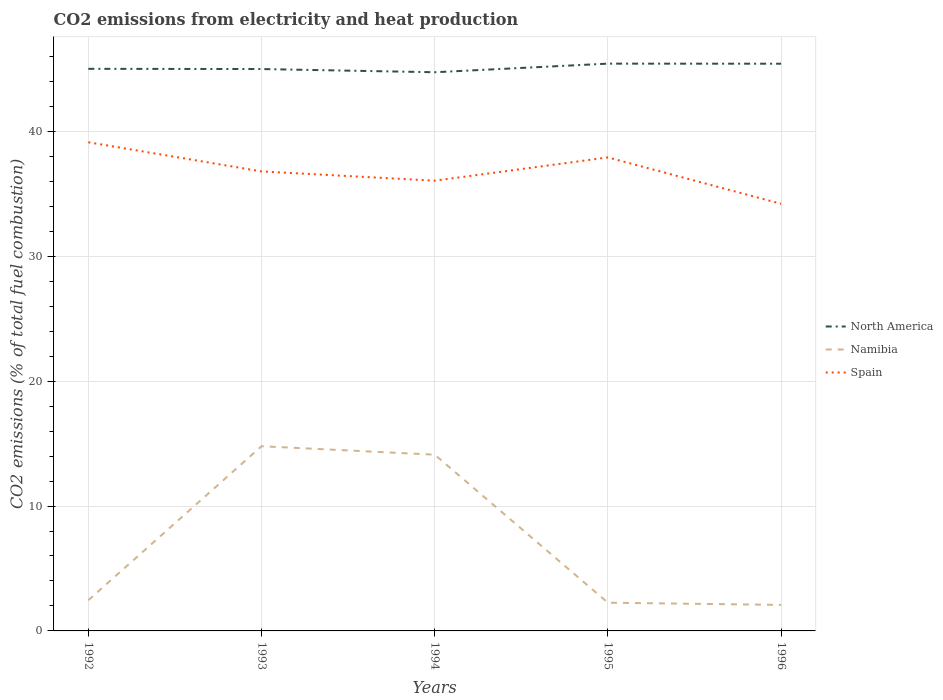How many different coloured lines are there?
Offer a very short reply. 3. Across all years, what is the maximum amount of CO2 emitted in North America?
Your response must be concise. 44.73. In which year was the amount of CO2 emitted in Spain maximum?
Your response must be concise. 1996. What is the total amount of CO2 emitted in Namibia in the graph?
Offer a very short reply. 0.68. What is the difference between the highest and the second highest amount of CO2 emitted in Spain?
Offer a terse response. 4.93. How many years are there in the graph?
Provide a short and direct response. 5. What is the difference between two consecutive major ticks on the Y-axis?
Your answer should be compact. 10. Are the values on the major ticks of Y-axis written in scientific E-notation?
Offer a very short reply. No. Does the graph contain any zero values?
Provide a succinct answer. No. How are the legend labels stacked?
Ensure brevity in your answer.  Vertical. What is the title of the graph?
Make the answer very short. CO2 emissions from electricity and heat production. What is the label or title of the Y-axis?
Your response must be concise. CO2 emissions (% of total fuel combustion). What is the CO2 emissions (% of total fuel combustion) of North America in 1992?
Make the answer very short. 45.01. What is the CO2 emissions (% of total fuel combustion) of Namibia in 1992?
Offer a terse response. 2.46. What is the CO2 emissions (% of total fuel combustion) of Spain in 1992?
Offer a very short reply. 39.12. What is the CO2 emissions (% of total fuel combustion) of North America in 1993?
Provide a short and direct response. 44.99. What is the CO2 emissions (% of total fuel combustion) of Namibia in 1993?
Your answer should be very brief. 14.79. What is the CO2 emissions (% of total fuel combustion) of Spain in 1993?
Give a very brief answer. 36.79. What is the CO2 emissions (% of total fuel combustion) in North America in 1994?
Keep it short and to the point. 44.73. What is the CO2 emissions (% of total fuel combustion) of Namibia in 1994?
Offer a very short reply. 14.11. What is the CO2 emissions (% of total fuel combustion) in Spain in 1994?
Provide a short and direct response. 36.05. What is the CO2 emissions (% of total fuel combustion) in North America in 1995?
Offer a very short reply. 45.42. What is the CO2 emissions (% of total fuel combustion) of Namibia in 1995?
Give a very brief answer. 2.26. What is the CO2 emissions (% of total fuel combustion) in Spain in 1995?
Provide a short and direct response. 37.91. What is the CO2 emissions (% of total fuel combustion) in North America in 1996?
Your answer should be very brief. 45.42. What is the CO2 emissions (% of total fuel combustion) of Namibia in 1996?
Keep it short and to the point. 2.08. What is the CO2 emissions (% of total fuel combustion) in Spain in 1996?
Make the answer very short. 34.2. Across all years, what is the maximum CO2 emissions (% of total fuel combustion) in North America?
Keep it short and to the point. 45.42. Across all years, what is the maximum CO2 emissions (% of total fuel combustion) of Namibia?
Provide a short and direct response. 14.79. Across all years, what is the maximum CO2 emissions (% of total fuel combustion) of Spain?
Ensure brevity in your answer.  39.12. Across all years, what is the minimum CO2 emissions (% of total fuel combustion) in North America?
Ensure brevity in your answer.  44.73. Across all years, what is the minimum CO2 emissions (% of total fuel combustion) of Namibia?
Provide a short and direct response. 2.08. Across all years, what is the minimum CO2 emissions (% of total fuel combustion) in Spain?
Your answer should be very brief. 34.2. What is the total CO2 emissions (% of total fuel combustion) in North America in the graph?
Offer a terse response. 225.56. What is the total CO2 emissions (% of total fuel combustion) in Namibia in the graph?
Your response must be concise. 35.7. What is the total CO2 emissions (% of total fuel combustion) of Spain in the graph?
Your answer should be compact. 184.08. What is the difference between the CO2 emissions (% of total fuel combustion) of North America in 1992 and that in 1993?
Your answer should be compact. 0.02. What is the difference between the CO2 emissions (% of total fuel combustion) of Namibia in 1992 and that in 1993?
Provide a succinct answer. -12.33. What is the difference between the CO2 emissions (% of total fuel combustion) of Spain in 1992 and that in 1993?
Ensure brevity in your answer.  2.33. What is the difference between the CO2 emissions (% of total fuel combustion) of North America in 1992 and that in 1994?
Give a very brief answer. 0.27. What is the difference between the CO2 emissions (% of total fuel combustion) in Namibia in 1992 and that in 1994?
Your answer should be compact. -11.65. What is the difference between the CO2 emissions (% of total fuel combustion) in Spain in 1992 and that in 1994?
Your answer should be compact. 3.08. What is the difference between the CO2 emissions (% of total fuel combustion) of North America in 1992 and that in 1995?
Keep it short and to the point. -0.42. What is the difference between the CO2 emissions (% of total fuel combustion) of Namibia in 1992 and that in 1995?
Your answer should be very brief. 0.2. What is the difference between the CO2 emissions (% of total fuel combustion) of Spain in 1992 and that in 1995?
Your response must be concise. 1.21. What is the difference between the CO2 emissions (% of total fuel combustion) in North America in 1992 and that in 1996?
Give a very brief answer. -0.41. What is the difference between the CO2 emissions (% of total fuel combustion) of Namibia in 1992 and that in 1996?
Your answer should be compact. 0.38. What is the difference between the CO2 emissions (% of total fuel combustion) of Spain in 1992 and that in 1996?
Make the answer very short. 4.93. What is the difference between the CO2 emissions (% of total fuel combustion) in North America in 1993 and that in 1994?
Your response must be concise. 0.26. What is the difference between the CO2 emissions (% of total fuel combustion) of Namibia in 1993 and that in 1994?
Your response must be concise. 0.68. What is the difference between the CO2 emissions (% of total fuel combustion) in Spain in 1993 and that in 1994?
Offer a very short reply. 0.74. What is the difference between the CO2 emissions (% of total fuel combustion) in North America in 1993 and that in 1995?
Your response must be concise. -0.43. What is the difference between the CO2 emissions (% of total fuel combustion) in Namibia in 1993 and that in 1995?
Your answer should be compact. 12.53. What is the difference between the CO2 emissions (% of total fuel combustion) in Spain in 1993 and that in 1995?
Give a very brief answer. -1.12. What is the difference between the CO2 emissions (% of total fuel combustion) in North America in 1993 and that in 1996?
Keep it short and to the point. -0.43. What is the difference between the CO2 emissions (% of total fuel combustion) of Namibia in 1993 and that in 1996?
Offer a terse response. 12.71. What is the difference between the CO2 emissions (% of total fuel combustion) in Spain in 1993 and that in 1996?
Your answer should be very brief. 2.59. What is the difference between the CO2 emissions (% of total fuel combustion) in North America in 1994 and that in 1995?
Keep it short and to the point. -0.69. What is the difference between the CO2 emissions (% of total fuel combustion) in Namibia in 1994 and that in 1995?
Offer a very short reply. 11.85. What is the difference between the CO2 emissions (% of total fuel combustion) of Spain in 1994 and that in 1995?
Offer a terse response. -1.86. What is the difference between the CO2 emissions (% of total fuel combustion) of North America in 1994 and that in 1996?
Offer a very short reply. -0.68. What is the difference between the CO2 emissions (% of total fuel combustion) in Namibia in 1994 and that in 1996?
Give a very brief answer. 12.03. What is the difference between the CO2 emissions (% of total fuel combustion) in Spain in 1994 and that in 1996?
Give a very brief answer. 1.85. What is the difference between the CO2 emissions (% of total fuel combustion) of North America in 1995 and that in 1996?
Offer a terse response. 0.01. What is the difference between the CO2 emissions (% of total fuel combustion) in Namibia in 1995 and that in 1996?
Your response must be concise. 0.18. What is the difference between the CO2 emissions (% of total fuel combustion) of Spain in 1995 and that in 1996?
Offer a terse response. 3.71. What is the difference between the CO2 emissions (% of total fuel combustion) in North America in 1992 and the CO2 emissions (% of total fuel combustion) in Namibia in 1993?
Provide a succinct answer. 30.22. What is the difference between the CO2 emissions (% of total fuel combustion) in North America in 1992 and the CO2 emissions (% of total fuel combustion) in Spain in 1993?
Your answer should be compact. 8.21. What is the difference between the CO2 emissions (% of total fuel combustion) in Namibia in 1992 and the CO2 emissions (% of total fuel combustion) in Spain in 1993?
Ensure brevity in your answer.  -34.33. What is the difference between the CO2 emissions (% of total fuel combustion) of North America in 1992 and the CO2 emissions (% of total fuel combustion) of Namibia in 1994?
Provide a succinct answer. 30.9. What is the difference between the CO2 emissions (% of total fuel combustion) in North America in 1992 and the CO2 emissions (% of total fuel combustion) in Spain in 1994?
Your answer should be compact. 8.96. What is the difference between the CO2 emissions (% of total fuel combustion) of Namibia in 1992 and the CO2 emissions (% of total fuel combustion) of Spain in 1994?
Your answer should be compact. -33.59. What is the difference between the CO2 emissions (% of total fuel combustion) in North America in 1992 and the CO2 emissions (% of total fuel combustion) in Namibia in 1995?
Keep it short and to the point. 42.75. What is the difference between the CO2 emissions (% of total fuel combustion) of North America in 1992 and the CO2 emissions (% of total fuel combustion) of Spain in 1995?
Make the answer very short. 7.09. What is the difference between the CO2 emissions (% of total fuel combustion) of Namibia in 1992 and the CO2 emissions (% of total fuel combustion) of Spain in 1995?
Your answer should be very brief. -35.45. What is the difference between the CO2 emissions (% of total fuel combustion) in North America in 1992 and the CO2 emissions (% of total fuel combustion) in Namibia in 1996?
Keep it short and to the point. 42.92. What is the difference between the CO2 emissions (% of total fuel combustion) in North America in 1992 and the CO2 emissions (% of total fuel combustion) in Spain in 1996?
Ensure brevity in your answer.  10.81. What is the difference between the CO2 emissions (% of total fuel combustion) in Namibia in 1992 and the CO2 emissions (% of total fuel combustion) in Spain in 1996?
Your answer should be very brief. -31.74. What is the difference between the CO2 emissions (% of total fuel combustion) of North America in 1993 and the CO2 emissions (% of total fuel combustion) of Namibia in 1994?
Ensure brevity in your answer.  30.88. What is the difference between the CO2 emissions (% of total fuel combustion) of North America in 1993 and the CO2 emissions (% of total fuel combustion) of Spain in 1994?
Offer a terse response. 8.94. What is the difference between the CO2 emissions (% of total fuel combustion) in Namibia in 1993 and the CO2 emissions (% of total fuel combustion) in Spain in 1994?
Your answer should be compact. -21.26. What is the difference between the CO2 emissions (% of total fuel combustion) of North America in 1993 and the CO2 emissions (% of total fuel combustion) of Namibia in 1995?
Provide a short and direct response. 42.73. What is the difference between the CO2 emissions (% of total fuel combustion) in North America in 1993 and the CO2 emissions (% of total fuel combustion) in Spain in 1995?
Make the answer very short. 7.07. What is the difference between the CO2 emissions (% of total fuel combustion) of Namibia in 1993 and the CO2 emissions (% of total fuel combustion) of Spain in 1995?
Offer a terse response. -23.12. What is the difference between the CO2 emissions (% of total fuel combustion) in North America in 1993 and the CO2 emissions (% of total fuel combustion) in Namibia in 1996?
Your answer should be compact. 42.9. What is the difference between the CO2 emissions (% of total fuel combustion) in North America in 1993 and the CO2 emissions (% of total fuel combustion) in Spain in 1996?
Ensure brevity in your answer.  10.79. What is the difference between the CO2 emissions (% of total fuel combustion) of Namibia in 1993 and the CO2 emissions (% of total fuel combustion) of Spain in 1996?
Your answer should be compact. -19.41. What is the difference between the CO2 emissions (% of total fuel combustion) in North America in 1994 and the CO2 emissions (% of total fuel combustion) in Namibia in 1995?
Keep it short and to the point. 42.47. What is the difference between the CO2 emissions (% of total fuel combustion) in North America in 1994 and the CO2 emissions (% of total fuel combustion) in Spain in 1995?
Offer a very short reply. 6.82. What is the difference between the CO2 emissions (% of total fuel combustion) of Namibia in 1994 and the CO2 emissions (% of total fuel combustion) of Spain in 1995?
Your answer should be compact. -23.8. What is the difference between the CO2 emissions (% of total fuel combustion) in North America in 1994 and the CO2 emissions (% of total fuel combustion) in Namibia in 1996?
Your response must be concise. 42.65. What is the difference between the CO2 emissions (% of total fuel combustion) in North America in 1994 and the CO2 emissions (% of total fuel combustion) in Spain in 1996?
Give a very brief answer. 10.53. What is the difference between the CO2 emissions (% of total fuel combustion) in Namibia in 1994 and the CO2 emissions (% of total fuel combustion) in Spain in 1996?
Offer a terse response. -20.09. What is the difference between the CO2 emissions (% of total fuel combustion) in North America in 1995 and the CO2 emissions (% of total fuel combustion) in Namibia in 1996?
Your answer should be compact. 43.34. What is the difference between the CO2 emissions (% of total fuel combustion) in North America in 1995 and the CO2 emissions (% of total fuel combustion) in Spain in 1996?
Offer a terse response. 11.22. What is the difference between the CO2 emissions (% of total fuel combustion) of Namibia in 1995 and the CO2 emissions (% of total fuel combustion) of Spain in 1996?
Provide a succinct answer. -31.94. What is the average CO2 emissions (% of total fuel combustion) in North America per year?
Ensure brevity in your answer.  45.11. What is the average CO2 emissions (% of total fuel combustion) in Namibia per year?
Offer a terse response. 7.14. What is the average CO2 emissions (% of total fuel combustion) in Spain per year?
Your response must be concise. 36.82. In the year 1992, what is the difference between the CO2 emissions (% of total fuel combustion) of North America and CO2 emissions (% of total fuel combustion) of Namibia?
Your answer should be very brief. 42.55. In the year 1992, what is the difference between the CO2 emissions (% of total fuel combustion) in North America and CO2 emissions (% of total fuel combustion) in Spain?
Offer a very short reply. 5.88. In the year 1992, what is the difference between the CO2 emissions (% of total fuel combustion) in Namibia and CO2 emissions (% of total fuel combustion) in Spain?
Offer a very short reply. -36.67. In the year 1993, what is the difference between the CO2 emissions (% of total fuel combustion) in North America and CO2 emissions (% of total fuel combustion) in Namibia?
Your response must be concise. 30.2. In the year 1993, what is the difference between the CO2 emissions (% of total fuel combustion) of North America and CO2 emissions (% of total fuel combustion) of Spain?
Make the answer very short. 8.2. In the year 1993, what is the difference between the CO2 emissions (% of total fuel combustion) in Namibia and CO2 emissions (% of total fuel combustion) in Spain?
Provide a short and direct response. -22. In the year 1994, what is the difference between the CO2 emissions (% of total fuel combustion) in North America and CO2 emissions (% of total fuel combustion) in Namibia?
Your response must be concise. 30.62. In the year 1994, what is the difference between the CO2 emissions (% of total fuel combustion) of North America and CO2 emissions (% of total fuel combustion) of Spain?
Give a very brief answer. 8.68. In the year 1994, what is the difference between the CO2 emissions (% of total fuel combustion) in Namibia and CO2 emissions (% of total fuel combustion) in Spain?
Ensure brevity in your answer.  -21.94. In the year 1995, what is the difference between the CO2 emissions (% of total fuel combustion) in North America and CO2 emissions (% of total fuel combustion) in Namibia?
Offer a very short reply. 43.16. In the year 1995, what is the difference between the CO2 emissions (% of total fuel combustion) of North America and CO2 emissions (% of total fuel combustion) of Spain?
Provide a short and direct response. 7.51. In the year 1995, what is the difference between the CO2 emissions (% of total fuel combustion) in Namibia and CO2 emissions (% of total fuel combustion) in Spain?
Offer a very short reply. -35.65. In the year 1996, what is the difference between the CO2 emissions (% of total fuel combustion) in North America and CO2 emissions (% of total fuel combustion) in Namibia?
Provide a short and direct response. 43.33. In the year 1996, what is the difference between the CO2 emissions (% of total fuel combustion) in North America and CO2 emissions (% of total fuel combustion) in Spain?
Ensure brevity in your answer.  11.22. In the year 1996, what is the difference between the CO2 emissions (% of total fuel combustion) in Namibia and CO2 emissions (% of total fuel combustion) in Spain?
Keep it short and to the point. -32.11. What is the ratio of the CO2 emissions (% of total fuel combustion) of North America in 1992 to that in 1993?
Provide a succinct answer. 1. What is the ratio of the CO2 emissions (% of total fuel combustion) in Namibia in 1992 to that in 1993?
Offer a terse response. 0.17. What is the ratio of the CO2 emissions (% of total fuel combustion) in Spain in 1992 to that in 1993?
Give a very brief answer. 1.06. What is the ratio of the CO2 emissions (% of total fuel combustion) of Namibia in 1992 to that in 1994?
Your answer should be compact. 0.17. What is the ratio of the CO2 emissions (% of total fuel combustion) in Spain in 1992 to that in 1994?
Offer a terse response. 1.09. What is the ratio of the CO2 emissions (% of total fuel combustion) in North America in 1992 to that in 1995?
Provide a short and direct response. 0.99. What is the ratio of the CO2 emissions (% of total fuel combustion) in Namibia in 1992 to that in 1995?
Keep it short and to the point. 1.09. What is the ratio of the CO2 emissions (% of total fuel combustion) in Spain in 1992 to that in 1995?
Offer a terse response. 1.03. What is the ratio of the CO2 emissions (% of total fuel combustion) of Namibia in 1992 to that in 1996?
Keep it short and to the point. 1.18. What is the ratio of the CO2 emissions (% of total fuel combustion) in Spain in 1992 to that in 1996?
Provide a succinct answer. 1.14. What is the ratio of the CO2 emissions (% of total fuel combustion) in North America in 1993 to that in 1994?
Your answer should be very brief. 1.01. What is the ratio of the CO2 emissions (% of total fuel combustion) of Namibia in 1993 to that in 1994?
Make the answer very short. 1.05. What is the ratio of the CO2 emissions (% of total fuel combustion) in Spain in 1993 to that in 1994?
Provide a short and direct response. 1.02. What is the ratio of the CO2 emissions (% of total fuel combustion) in North America in 1993 to that in 1995?
Your answer should be compact. 0.99. What is the ratio of the CO2 emissions (% of total fuel combustion) in Namibia in 1993 to that in 1995?
Make the answer very short. 6.54. What is the ratio of the CO2 emissions (% of total fuel combustion) in Spain in 1993 to that in 1995?
Offer a terse response. 0.97. What is the ratio of the CO2 emissions (% of total fuel combustion) in North America in 1993 to that in 1996?
Your answer should be very brief. 0.99. What is the ratio of the CO2 emissions (% of total fuel combustion) of Namibia in 1993 to that in 1996?
Your response must be concise. 7.1. What is the ratio of the CO2 emissions (% of total fuel combustion) of Spain in 1993 to that in 1996?
Offer a terse response. 1.08. What is the ratio of the CO2 emissions (% of total fuel combustion) of Namibia in 1994 to that in 1995?
Provide a succinct answer. 6.24. What is the ratio of the CO2 emissions (% of total fuel combustion) of Spain in 1994 to that in 1995?
Provide a succinct answer. 0.95. What is the ratio of the CO2 emissions (% of total fuel combustion) of Namibia in 1994 to that in 1996?
Provide a succinct answer. 6.77. What is the ratio of the CO2 emissions (% of total fuel combustion) of Spain in 1994 to that in 1996?
Provide a short and direct response. 1.05. What is the ratio of the CO2 emissions (% of total fuel combustion) of North America in 1995 to that in 1996?
Your response must be concise. 1. What is the ratio of the CO2 emissions (% of total fuel combustion) of Namibia in 1995 to that in 1996?
Keep it short and to the point. 1.08. What is the ratio of the CO2 emissions (% of total fuel combustion) of Spain in 1995 to that in 1996?
Your response must be concise. 1.11. What is the difference between the highest and the second highest CO2 emissions (% of total fuel combustion) in North America?
Offer a very short reply. 0.01. What is the difference between the highest and the second highest CO2 emissions (% of total fuel combustion) of Namibia?
Offer a very short reply. 0.68. What is the difference between the highest and the second highest CO2 emissions (% of total fuel combustion) of Spain?
Offer a very short reply. 1.21. What is the difference between the highest and the lowest CO2 emissions (% of total fuel combustion) in North America?
Offer a very short reply. 0.69. What is the difference between the highest and the lowest CO2 emissions (% of total fuel combustion) of Namibia?
Offer a very short reply. 12.71. What is the difference between the highest and the lowest CO2 emissions (% of total fuel combustion) of Spain?
Keep it short and to the point. 4.93. 